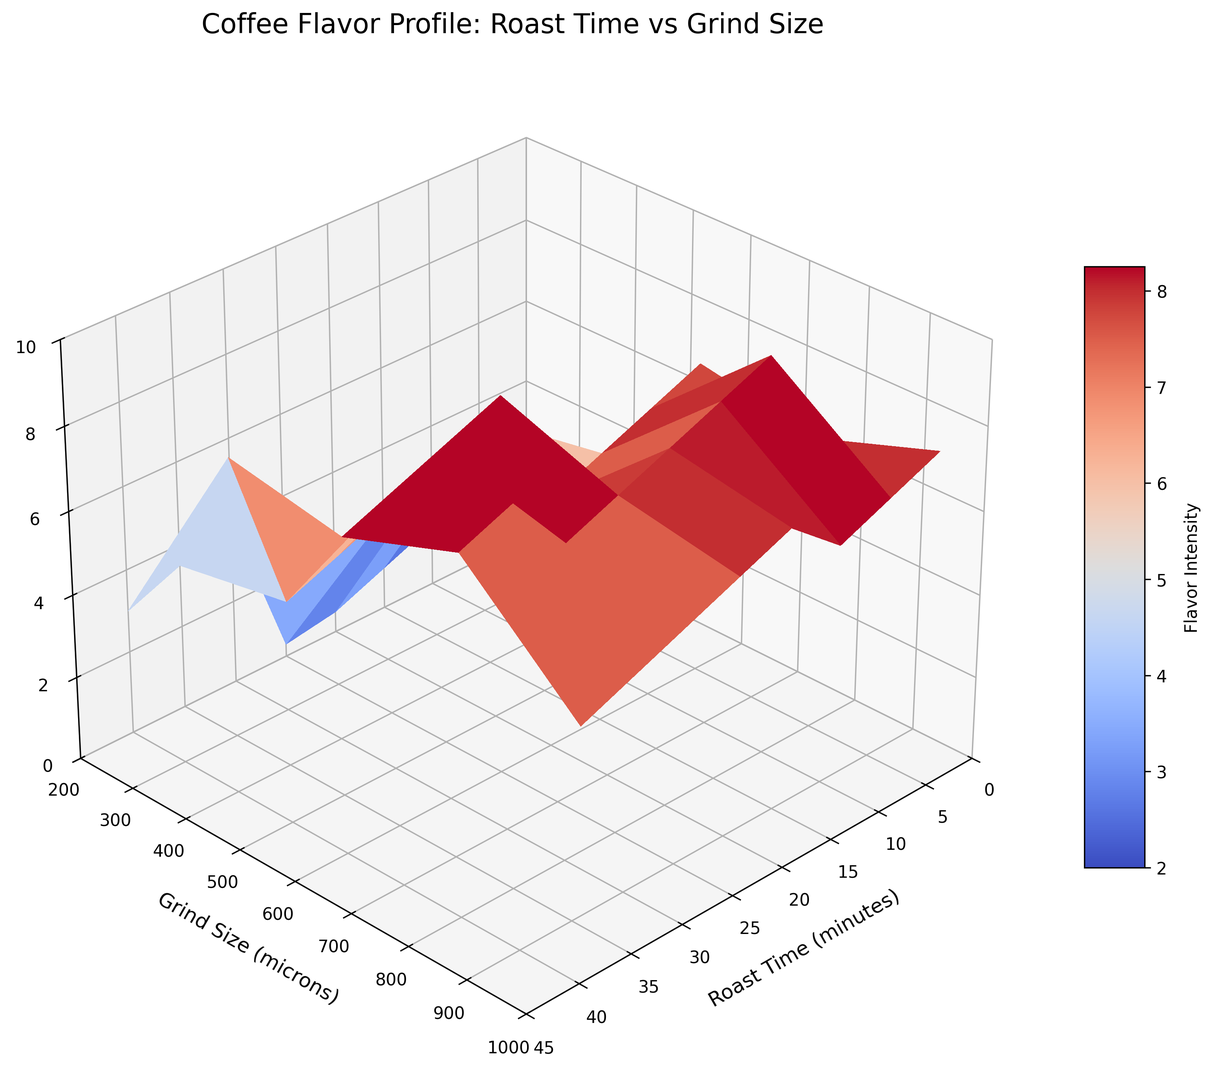What roast time and grind size combination gives the highest flavor intensity? To determine the highest flavor intensity, look for the peak value on the Z-axis (Flavor Intensity). It occurs at 30 minutes roast time and 200 microns grind size.
Answer: 30 minutes, 200 microns What is the flavor intensity for a 20-minute roast time and 600-micron grind size? Locate the flavor intensity at the intersection of 20 minutes roast time and 600 microns grind size on the 3D surface plot. It reads 7.0.
Answer: 7.0 For a fixed grind size of 1000 microns, how does flavor intensity change as roast time increases from 5 to 40 minutes? Observe the vertical line corresponding to 1000 microns across different roast times. It starts at 0.3 and increases to 6.0 at 20 minutes, then decreases to 6 at 40 minutes.
Answer: Increases initially, then stabilizes Which grind size would result in the lowest flavor intensity for a 10-minute roast time? Identify the values of flavor intensity corresponding to 10 minutes across different grind sizes. The lowest flavor intensity is at 1000 microns, with a value of 2.0.
Answer: 1000 microns For a roast time of 25 minutes, which grind size results in a flavor intensity of 8.5? Scan the surface for 25 minutes roast time; the grind size that gives a flavor intensity of 8.5 is 400 microns.
Answer: 400 microns What is the difference in flavor intensity between 15 and 35 minutes for a grind size of 400 microns? Compare the flavor intensities at 15 and 35 minutes for 400 microns grind size. They are 5.5 and 8.5 respectively. The difference is 8.5 - 5.5 = 3.0.
Answer: 3.0 At what grind size does the flavor intensity stabilize after 25 minutes of roast time? Examine the flavor intensity for roast times beyond 25 minutes. At 600, 800, and 1000 microns, flavor intensity stabilizes around 8, 7.5, and 7 respectively.
Answer: 600, 800, and 1000 microns Compare the flavor intensities at 10 and 40 minutes for a grind size of 200 microns. Which is higher? Observe the flavor intensities for 200 microns at 10 and 40 minutes. They are 4.0 and 8.0 respectively. The flavor intensity at 40 minutes is higher.
Answer: 40 minutes How does flavor intensity change when moving from 200 to 1000 microns for a fixed roast time of 30 minutes? Scan flavor intensities for 30 minutes across different grind sizes. It decreases from 9.5 at 200 microns to 7.5 at 1000 microns.
Answer: Decreases 